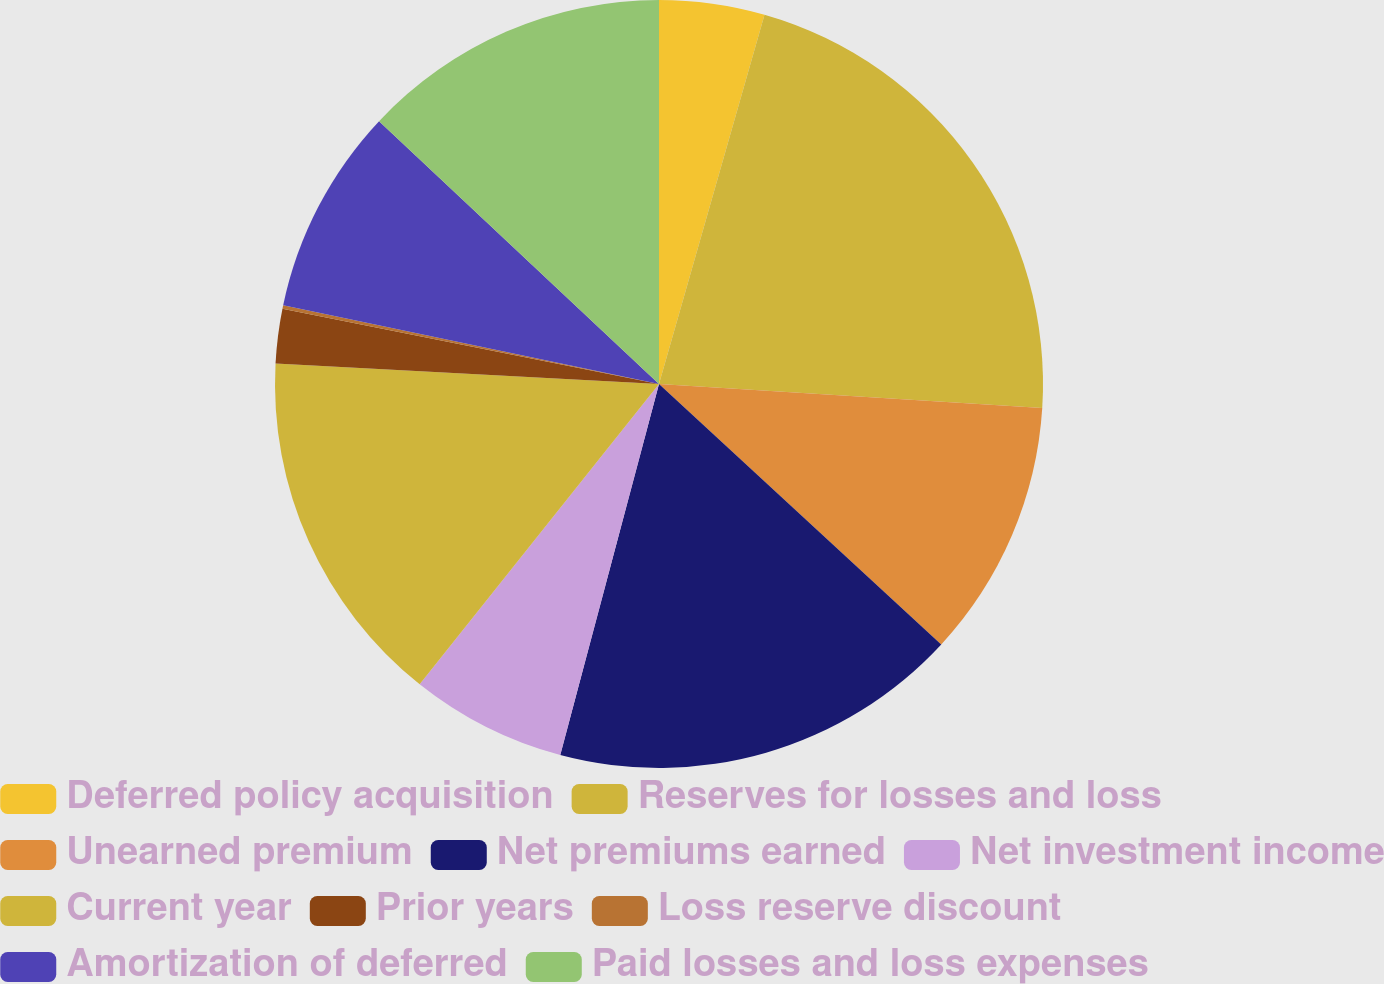Convert chart to OTSL. <chart><loc_0><loc_0><loc_500><loc_500><pie_chart><fcel>Deferred policy acquisition<fcel>Reserves for losses and loss<fcel>Unearned premium<fcel>Net premiums earned<fcel>Net investment income<fcel>Current year<fcel>Prior years<fcel>Loss reserve discount<fcel>Amortization of deferred<fcel>Paid losses and loss expenses<nl><fcel>4.43%<fcel>21.57%<fcel>10.86%<fcel>17.28%<fcel>6.57%<fcel>15.14%<fcel>2.29%<fcel>0.15%<fcel>8.71%<fcel>13.0%<nl></chart> 